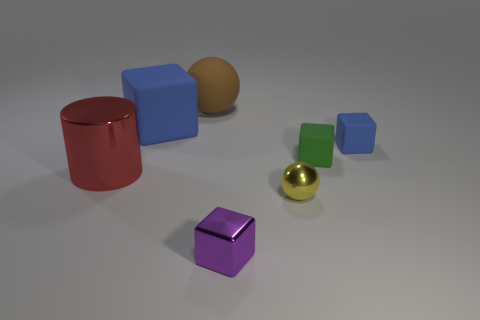What is the color of the big object that is the same shape as the tiny blue rubber thing?
Ensure brevity in your answer.  Blue. Are there any other things that have the same shape as the tiny purple metal thing?
Your answer should be compact. Yes. Do the large thing on the left side of the large blue block and the rubber sphere have the same color?
Give a very brief answer. No. There is a purple shiny thing that is the same shape as the small green rubber object; what is its size?
Ensure brevity in your answer.  Small. How many other big things are made of the same material as the large red object?
Make the answer very short. 0. There is a blue object that is left of the ball that is to the left of the small yellow metal thing; is there a big rubber block that is to the left of it?
Your answer should be very brief. No. What shape is the small purple metallic thing?
Make the answer very short. Cube. Is the tiny blue block on the right side of the metal block made of the same material as the blue thing that is to the left of the big brown sphere?
Provide a short and direct response. Yes. How many big rubber cubes have the same color as the tiny sphere?
Provide a succinct answer. 0. There is a tiny thing that is both to the left of the small blue matte thing and on the right side of the tiny ball; what is its shape?
Provide a short and direct response. Cube. 